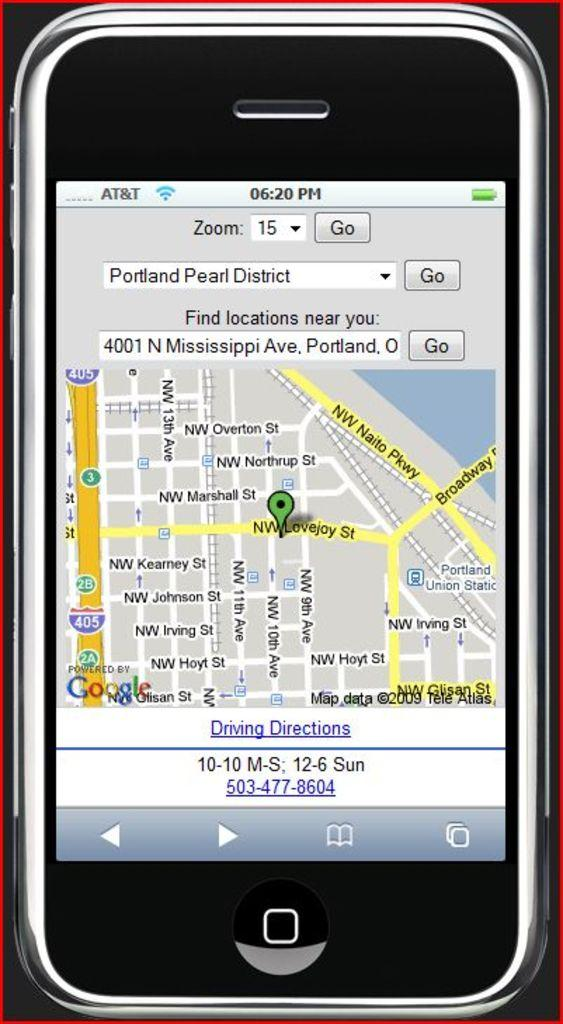<image>
Present a compact description of the photo's key features. The screen of a cell phone with a map pulled up that says driving directions on the bottom. 